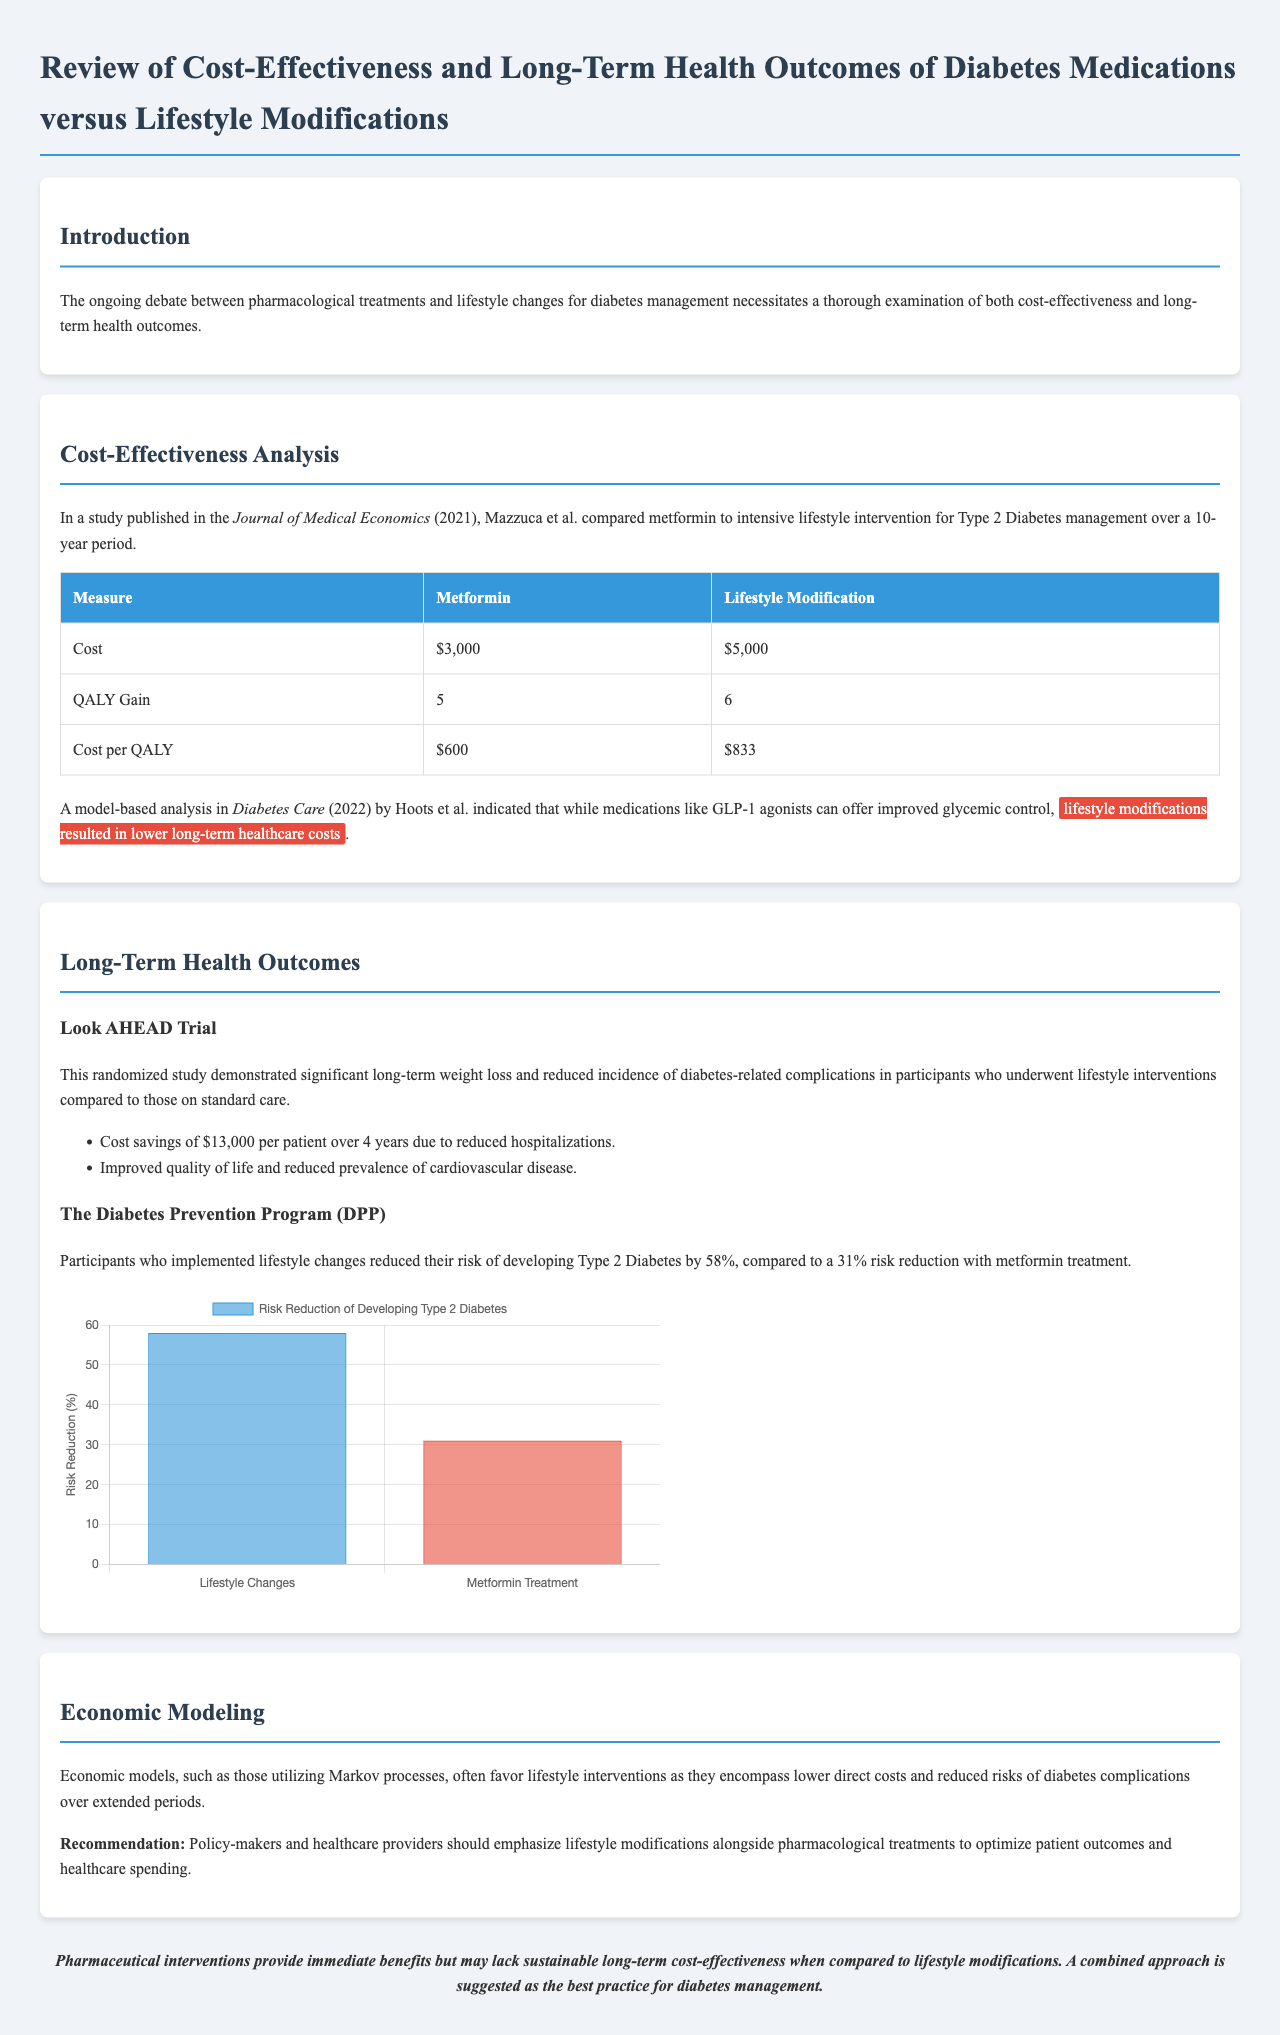What was the cost of Metformin? The cost of Metformin is stated in the table comparing medications to lifestyle modifications in the document.
Answer: $3,000 What is the QALY gain for Lifestyle Modification? The QALY gain for Lifestyle Modification is listed in the cost-effectiveness analysis section of the document.
Answer: 6 What trial is mentioned in relation to lifestyle interventions? The document references a specific trial that provides evidence on lifestyle interventions for diabetes.
Answer: Look AHEAD Trial What was the risk reduction percentage for participants using Lifestyle Changes according to the DPP? The percentage of risk reduction for Lifestyle Changes is provided in the discussion of the Diabetes Prevention Program.
Answer: 58% What are the direct costs associated with lifestyle interventions according to economic models? The economic modeling section suggests a specific spectrum of costs related to lifestyle interventions.
Answer: Lower direct costs Which medication showed a cost per QALY of $600? The document compares multiple interventions and their cost-effectiveness, specifying values for each.
Answer: Metformin What is the total cost savings per patient over 4 years mentioned for the Look AHEAD Trial? The Look AHEAD Trial results in significant cost savings for participants, specified in the document.
Answer: $13,000 What medication was analyzed alongside intensive lifestyle intervention in the study by Mazzuca et al.? The document identifies a specific medication that was compared to lifestyle modifications in the analysis.
Answer: Metformin 